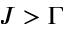Convert formula to latex. <formula><loc_0><loc_0><loc_500><loc_500>J > \Gamma</formula> 